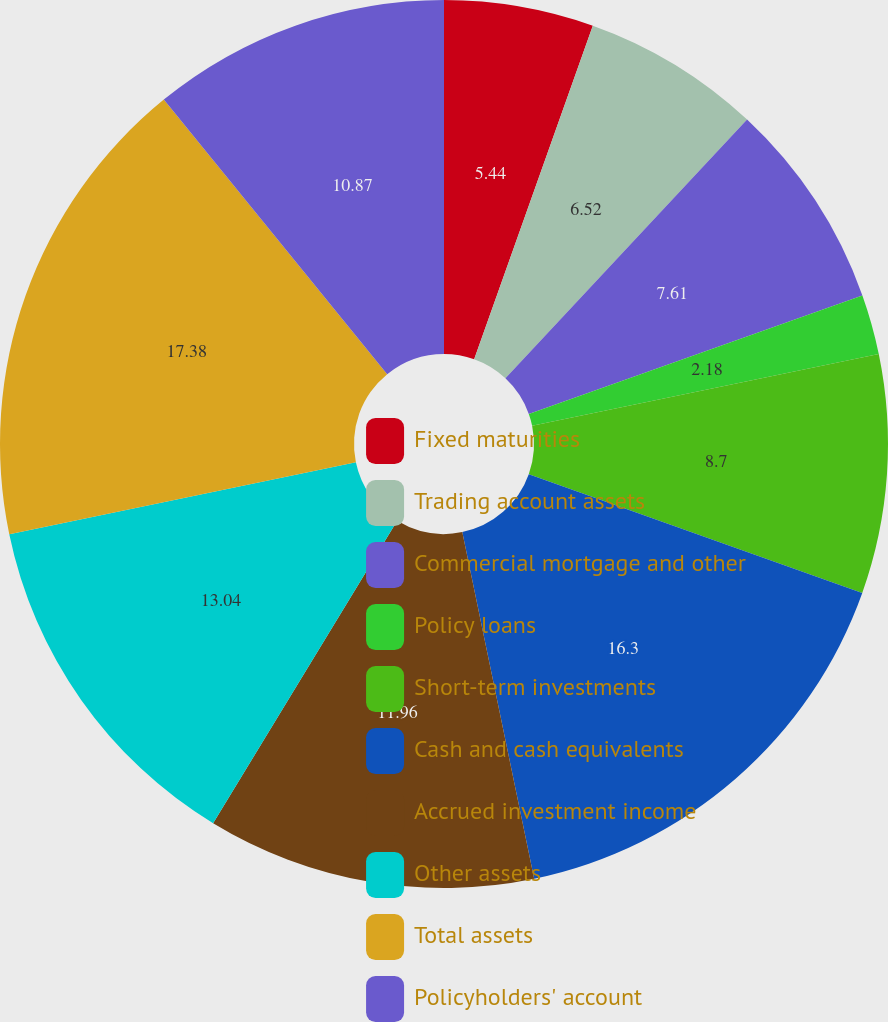<chart> <loc_0><loc_0><loc_500><loc_500><pie_chart><fcel>Fixed maturities<fcel>Trading account assets<fcel>Commercial mortgage and other<fcel>Policy loans<fcel>Short-term investments<fcel>Cash and cash equivalents<fcel>Accrued investment income<fcel>Other assets<fcel>Total assets<fcel>Policyholders' account<nl><fcel>5.44%<fcel>6.52%<fcel>7.61%<fcel>2.18%<fcel>8.7%<fcel>16.3%<fcel>11.96%<fcel>13.04%<fcel>17.39%<fcel>10.87%<nl></chart> 